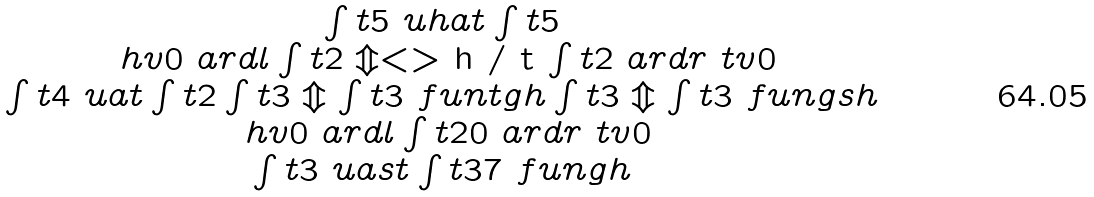<formula> <loc_0><loc_0><loc_500><loc_500>\begin{array} { c } \int t { 5 } \ u h a t \int t { 5 } \\ \ h v 0 \ a r d l \int t { 2 } \Updownarrow < > $ h / t $ \int t { 2 } \ a r d r \ t v 0 \\ \int t { 4 } \ u a t \int t { 2 } \int t { 3 } \Updownarrow \int t { 3 } \ f u n t g h \int t { 3 } \Updownarrow \int t { 3 } \ f u n g s h \\ \ h v 0 \ a r d l \int t { 2 0 } \ a r d r \ t v 0 \\ \int t { 3 } \ u a s t \int t { 3 7 } \ f u n g h \end{array}</formula> 